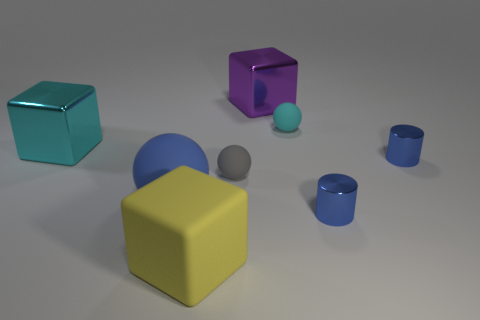Is there anything else that is the same size as the purple cube?
Keep it short and to the point. Yes. What size is the cyan block that is the same material as the purple object?
Offer a terse response. Large. What number of things are either cyan objects left of the large purple metal block or big metal things that are behind the cyan sphere?
Provide a short and direct response. 2. There is a cyan object in front of the cyan rubber thing; is it the same size as the small gray rubber object?
Your response must be concise. No. There is a shiny object behind the cyan metallic thing; what is its color?
Provide a succinct answer. Purple. What color is the matte thing that is the same shape as the large purple metallic object?
Offer a very short reply. Yellow. There is a small blue cylinder in front of the blue object left of the large purple metallic block; how many tiny blue cylinders are behind it?
Offer a terse response. 1. Is there anything else that is made of the same material as the large purple thing?
Your answer should be compact. Yes. Are there fewer tiny matte balls that are in front of the yellow rubber block than brown balls?
Give a very brief answer. No. Is the color of the big ball the same as the matte cube?
Provide a short and direct response. No. 